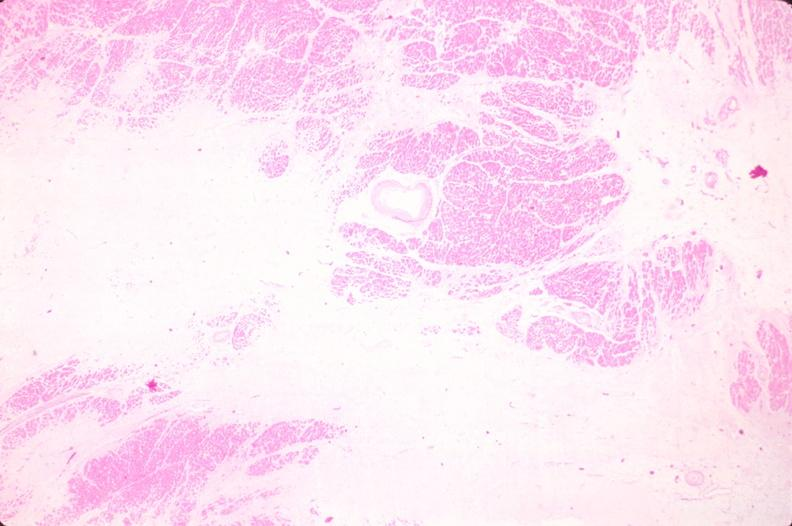s cardiovascular present?
Answer the question using a single word or phrase. Yes 